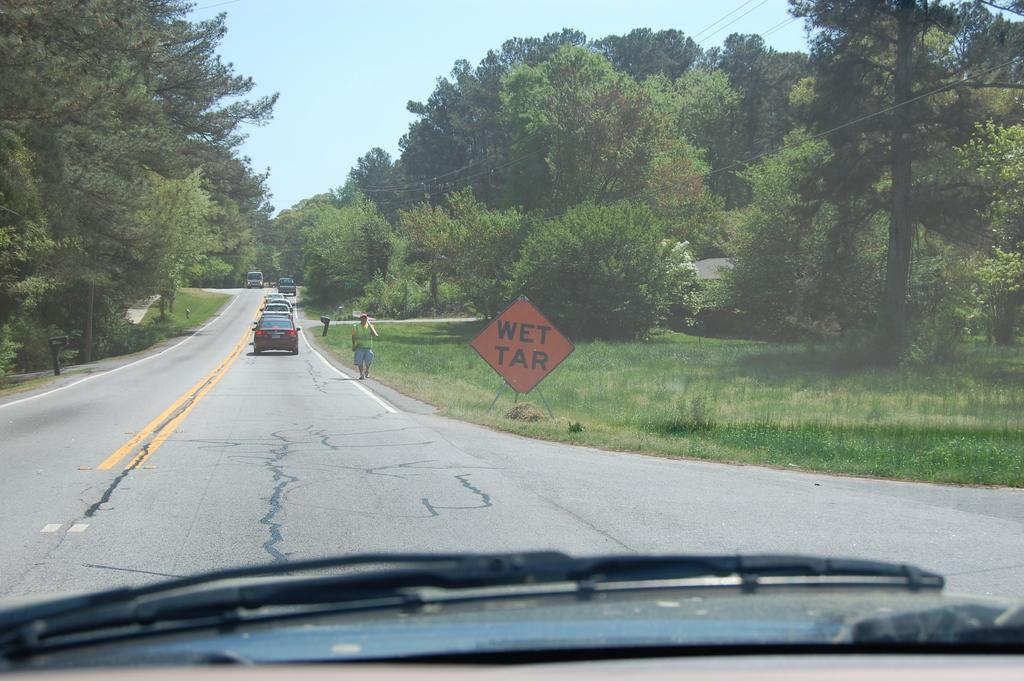What can be seen on the road in the image? There are vehicles on the road in the image. What is the person in the image doing? There is a person walking in the image. What type of vegetation is present in the image? There is a group of trees in the image. What object with a stand can be seen in the image? There is a board with a stand in the image. What type of infrastructure is visible in the image? Wires are visible in the image. How would you describe the weather in the image? The sky is visible in the image and appears cloudy. How many bikes are parked near the group of trees in the image? There are no bikes present in the image. Who is the guide leading the group of people in the image? There is no guide or group of people present in the image. What type of fruit is hanging from the wires in the image? There are no fruits or wires hanging in the image. 